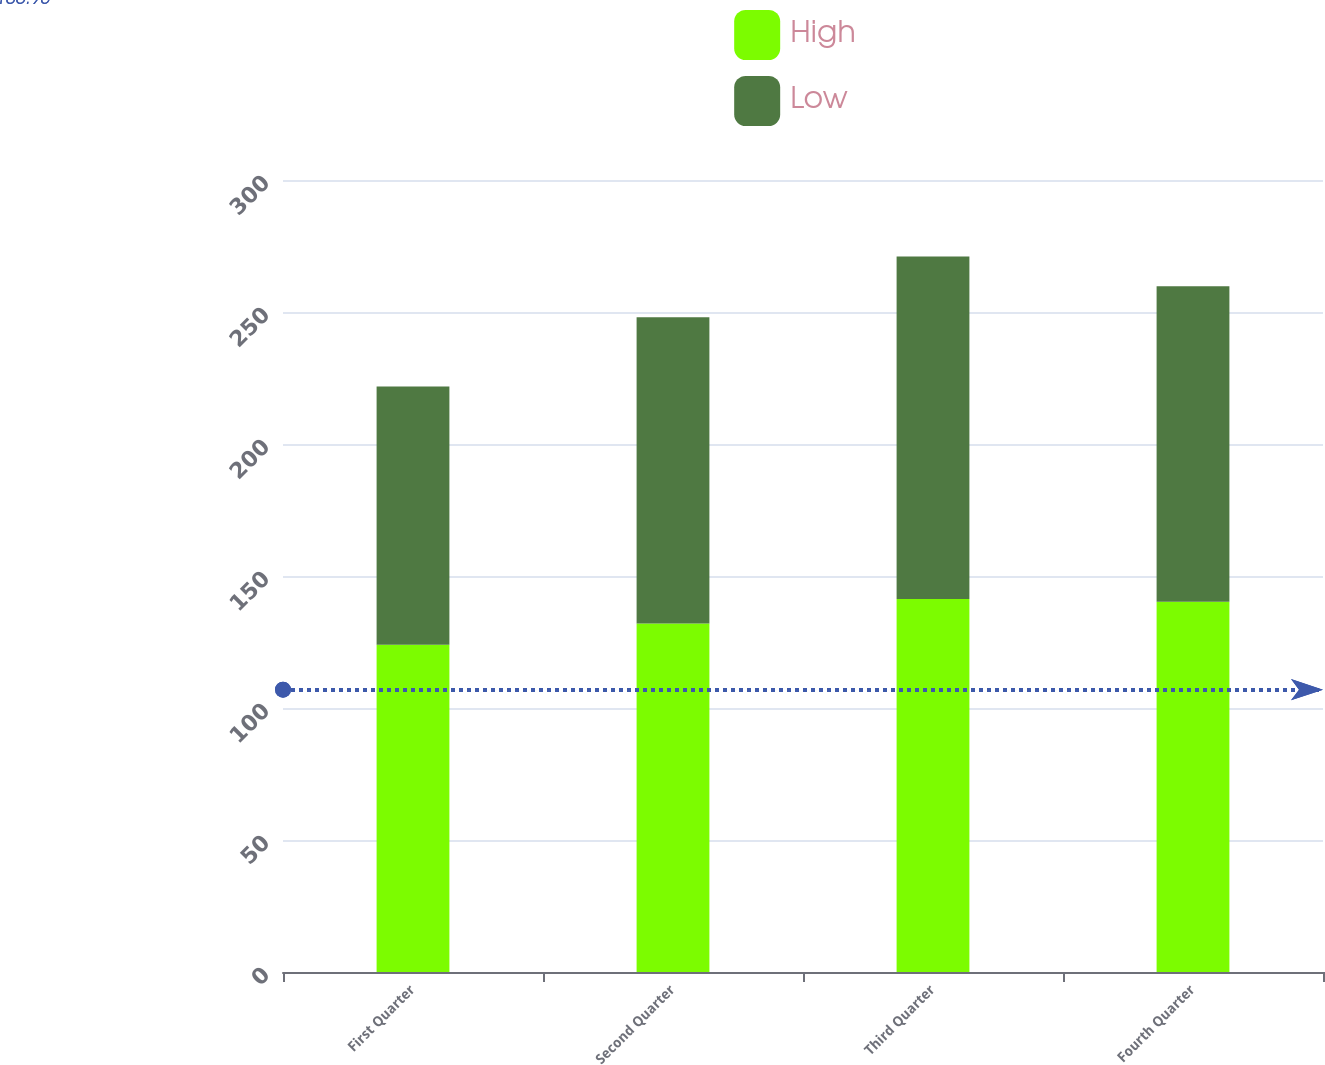Convert chart. <chart><loc_0><loc_0><loc_500><loc_500><stacked_bar_chart><ecel><fcel>First Quarter<fcel>Second Quarter<fcel>Third Quarter<fcel>Fourth Quarter<nl><fcel>High<fcel>123.99<fcel>131.99<fcel>141.32<fcel>140.27<nl><fcel>Low<fcel>97.79<fcel>115.98<fcel>129.68<fcel>119.51<nl></chart> 